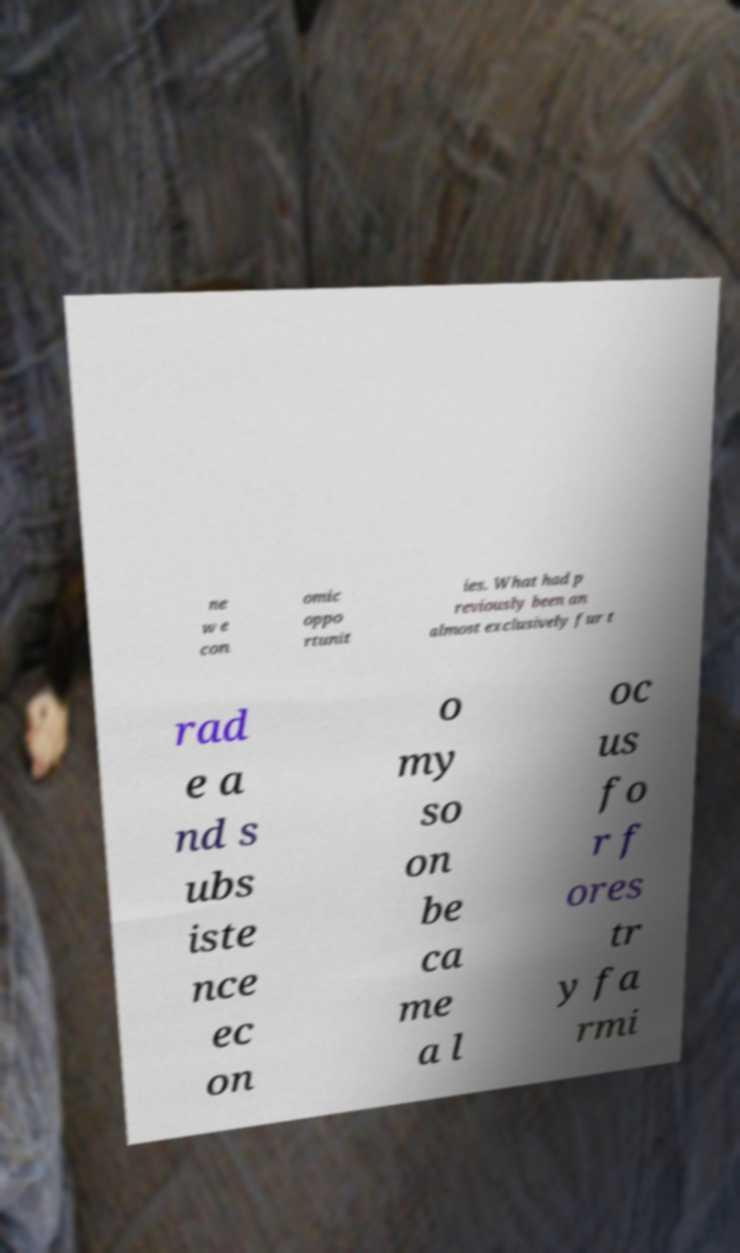Can you accurately transcribe the text from the provided image for me? ne w e con omic oppo rtunit ies. What had p reviously been an almost exclusively fur t rad e a nd s ubs iste nce ec on o my so on be ca me a l oc us fo r f ores tr y fa rmi 